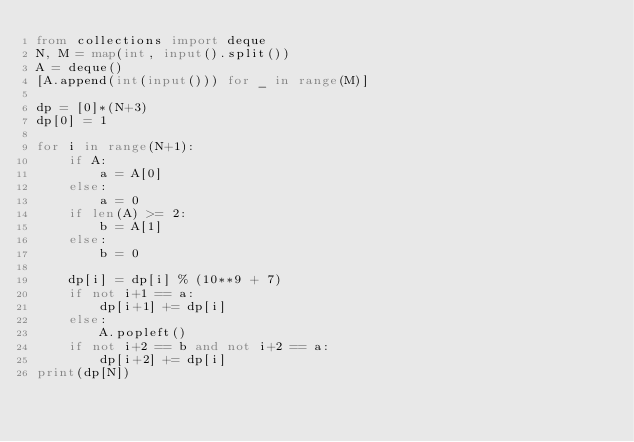<code> <loc_0><loc_0><loc_500><loc_500><_Python_>from collections import deque
N, M = map(int, input().split())
A = deque()
[A.append(int(input())) for _ in range(M)]

dp = [0]*(N+3)
dp[0] = 1

for i in range(N+1):
    if A:
        a = A[0]
    else:
        a = 0
    if len(A) >= 2:
        b = A[1]
    else:
        b = 0

    dp[i] = dp[i] % (10**9 + 7)
    if not i+1 == a:
        dp[i+1] += dp[i]
    else:
        A.popleft()
    if not i+2 == b and not i+2 == a:
        dp[i+2] += dp[i]
print(dp[N])
</code> 